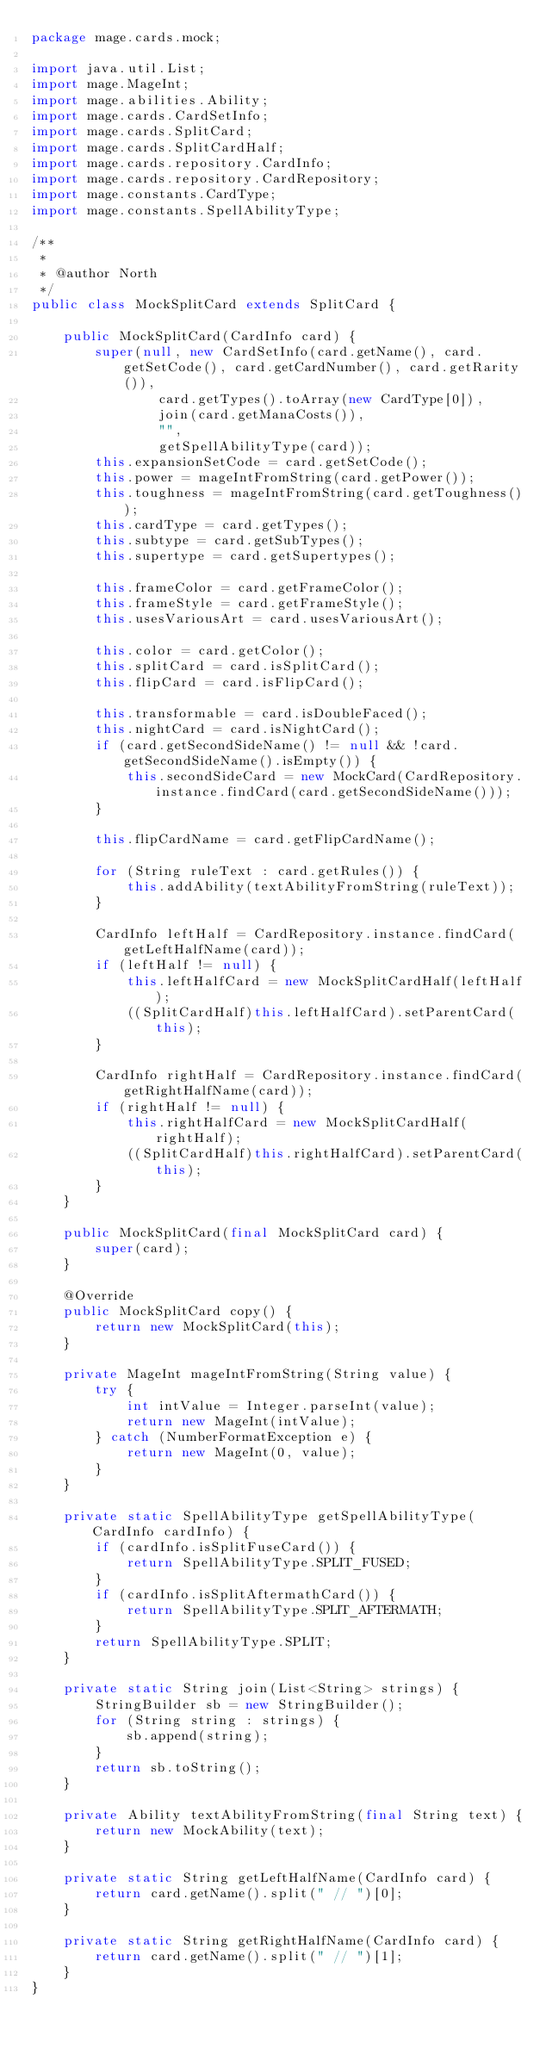<code> <loc_0><loc_0><loc_500><loc_500><_Java_>package mage.cards.mock;

import java.util.List;
import mage.MageInt;
import mage.abilities.Ability;
import mage.cards.CardSetInfo;
import mage.cards.SplitCard;
import mage.cards.SplitCardHalf;
import mage.cards.repository.CardInfo;
import mage.cards.repository.CardRepository;
import mage.constants.CardType;
import mage.constants.SpellAbilityType;

/**
 *
 * @author North
 */
public class MockSplitCard extends SplitCard {

    public MockSplitCard(CardInfo card) {
        super(null, new CardSetInfo(card.getName(), card.getSetCode(), card.getCardNumber(), card.getRarity()),
                card.getTypes().toArray(new CardType[0]),
                join(card.getManaCosts()),
                "",
                getSpellAbilityType(card));
        this.expansionSetCode = card.getSetCode();
        this.power = mageIntFromString(card.getPower());
        this.toughness = mageIntFromString(card.getToughness());
        this.cardType = card.getTypes();
        this.subtype = card.getSubTypes();
        this.supertype = card.getSupertypes();

        this.frameColor = card.getFrameColor();
        this.frameStyle = card.getFrameStyle();
        this.usesVariousArt = card.usesVariousArt();

        this.color = card.getColor();
        this.splitCard = card.isSplitCard();
        this.flipCard = card.isFlipCard();

        this.transformable = card.isDoubleFaced();
        this.nightCard = card.isNightCard();
        if (card.getSecondSideName() != null && !card.getSecondSideName().isEmpty()) {
            this.secondSideCard = new MockCard(CardRepository.instance.findCard(card.getSecondSideName()));
        }

        this.flipCardName = card.getFlipCardName();

        for (String ruleText : card.getRules()) {
            this.addAbility(textAbilityFromString(ruleText));
        }

        CardInfo leftHalf = CardRepository.instance.findCard(getLeftHalfName(card));
        if (leftHalf != null) {
            this.leftHalfCard = new MockSplitCardHalf(leftHalf);
            ((SplitCardHalf)this.leftHalfCard).setParentCard(this);
        }

        CardInfo rightHalf = CardRepository.instance.findCard(getRightHalfName(card));
        if (rightHalf != null) {
            this.rightHalfCard = new MockSplitCardHalf(rightHalf);
            ((SplitCardHalf)this.rightHalfCard).setParentCard(this);
        }
    }

    public MockSplitCard(final MockSplitCard card) {
        super(card);
    }

    @Override
    public MockSplitCard copy() {
        return new MockSplitCard(this);
    }

    private MageInt mageIntFromString(String value) {
        try {
            int intValue = Integer.parseInt(value);
            return new MageInt(intValue);
        } catch (NumberFormatException e) {
            return new MageInt(0, value);
        }
    }

    private static SpellAbilityType getSpellAbilityType(CardInfo cardInfo) {
        if (cardInfo.isSplitFuseCard()) {
            return SpellAbilityType.SPLIT_FUSED;
        }
        if (cardInfo.isSplitAftermathCard()) {
            return SpellAbilityType.SPLIT_AFTERMATH;
        }
        return SpellAbilityType.SPLIT;
    }

    private static String join(List<String> strings) {
        StringBuilder sb = new StringBuilder();
        for (String string : strings) {
            sb.append(string);
        }
        return sb.toString();
    }

    private Ability textAbilityFromString(final String text) {
        return new MockAbility(text);
    }

    private static String getLeftHalfName(CardInfo card) {
        return card.getName().split(" // ")[0];
    }

    private static String getRightHalfName(CardInfo card) {
        return card.getName().split(" // ")[1];
    }
}
</code> 